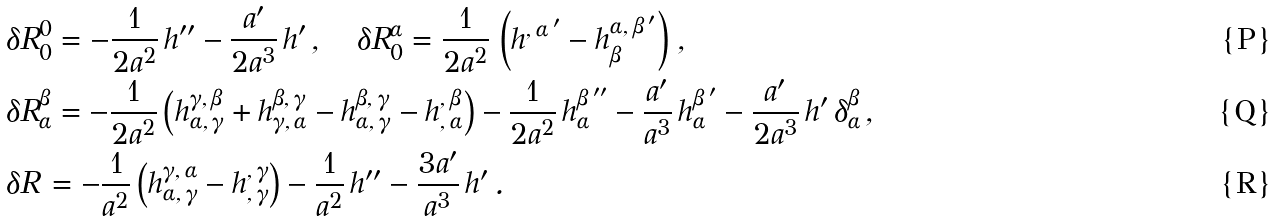Convert formula to latex. <formula><loc_0><loc_0><loc_500><loc_500>& \delta R _ { 0 } ^ { 0 } = - \frac { 1 } { 2 a ^ { 2 } } \, h ^ { \prime \prime } - \frac { a ^ { \prime } } { 2 a ^ { 3 } } \, h ^ { \prime } \, , \quad \delta R _ { 0 } ^ { \alpha } = \frac { 1 } { 2 a ^ { 2 } } \, \left ( h ^ { , \, \alpha \, ^ { \prime } } - h _ { \beta } ^ { \alpha , \, \beta \, ^ { \prime } } \right ) \, , \\ & \delta R _ { \alpha } ^ { \beta } = - \frac { 1 } { 2 a ^ { 2 } } \left ( h ^ { \gamma , \, \beta } _ { \alpha , \, \gamma } + h ^ { \beta , \, \gamma } _ { \gamma , \, \alpha } - h ^ { \beta , \, \gamma } _ { \alpha , \, \gamma } - h ^ { , \, \beta } _ { , \, \alpha } \right ) - \frac { 1 } { 2 a ^ { 2 } } \, h _ { \alpha } ^ { \beta \, ^ { \prime \prime } } - \frac { a ^ { \prime } } { a ^ { 3 } } \, h _ { \alpha } ^ { \beta \, ^ { \prime } } - \frac { a ^ { \prime } } { 2 a ^ { 3 } } \, h ^ { \prime } \, \delta _ { \alpha } ^ { \beta } \, , \\ & \delta R \, = - \frac { 1 } { a ^ { 2 } } \left ( h ^ { \gamma , \, \alpha } _ { \alpha , \, \gamma } - h ^ { , \, \gamma } _ { , \, \gamma } \right ) - \frac { 1 } { a ^ { 2 } } \, h ^ { \prime \prime } - \frac { 3 a ^ { \prime } } { a ^ { 3 } } \, h ^ { \prime } \, .</formula> 